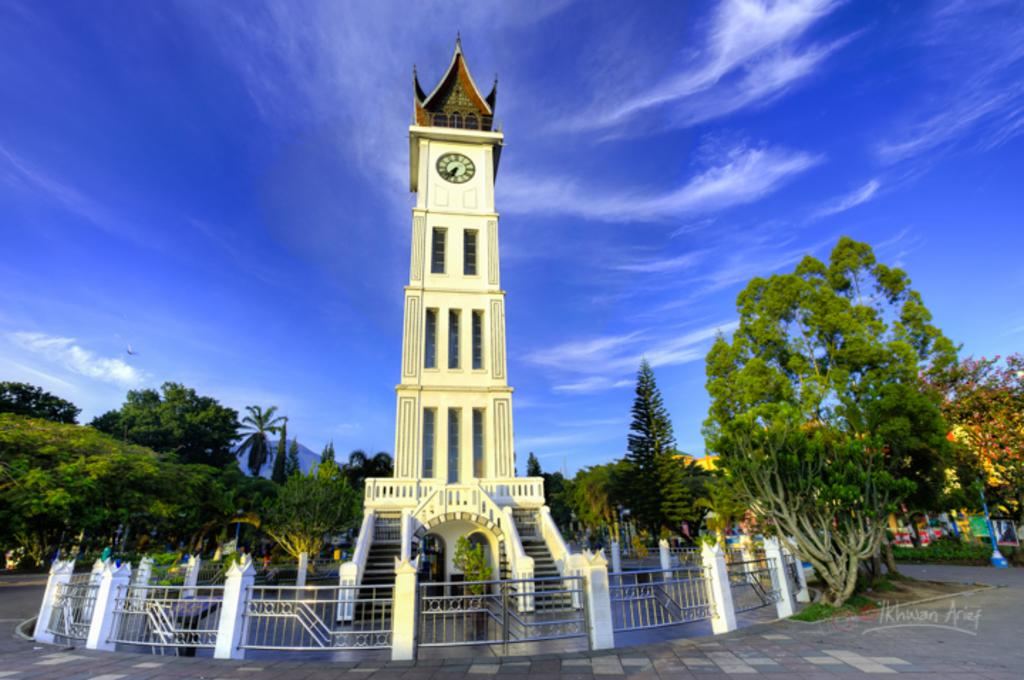What type of structure is present in the image? There is a building in the image. What time-telling device can be seen in the image? There is a clock in the image. What type of natural vegetation is visible in the background of the image? There are trees in the background of the image. What color is the pole visible in the background of the image? The pole is blue in color. What can be seen in the sky in the image? There are clouds visible in the sky. What part of the natural environment is visible in the background of the image? The sky is visible in the background of the image. Where is the cat hiding in the image? There is no cat present in the image. What shape is the box that the cat is playing with in the image? There is no box or cat present in the image. 